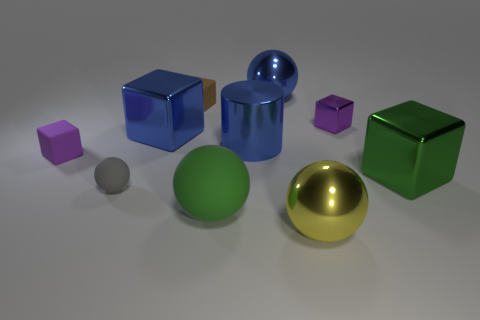Subtract all yellow metallic balls. How many balls are left? 3 Subtract all blue balls. How many balls are left? 3 Subtract 1 yellow spheres. How many objects are left? 9 Subtract all balls. How many objects are left? 6 Subtract 2 blocks. How many blocks are left? 3 Subtract all brown cubes. Subtract all gray balls. How many cubes are left? 4 Subtract all red cylinders. How many red cubes are left? 0 Subtract all purple rubber things. Subtract all gray rubber objects. How many objects are left? 8 Add 3 small cubes. How many small cubes are left? 6 Add 5 big metal balls. How many big metal balls exist? 7 